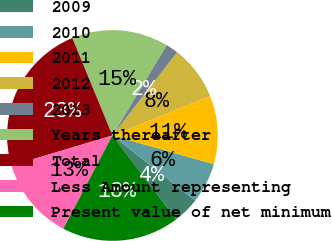Convert chart. <chart><loc_0><loc_0><loc_500><loc_500><pie_chart><fcel>2009<fcel>2010<fcel>2011<fcel>2012<fcel>2013<fcel>Years thereafter<fcel>Total<fcel>Less Amount representing<fcel>Present value of net minimum<nl><fcel>4.07%<fcel>6.21%<fcel>10.51%<fcel>8.36%<fcel>1.92%<fcel>14.81%<fcel>23.41%<fcel>12.66%<fcel>18.05%<nl></chart> 